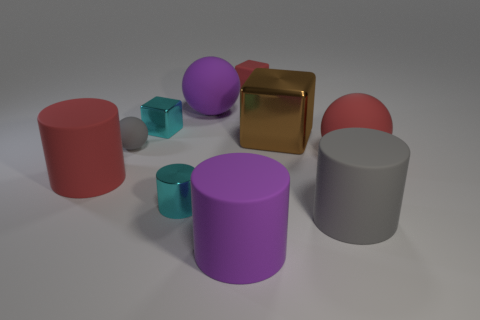The tiny cylinder has what color?
Your answer should be compact. Cyan. How many objects are shiny objects that are behind the tiny ball or green metallic spheres?
Make the answer very short. 2. Does the gray rubber cylinder that is in front of the large red rubber ball have the same size as the rubber cylinder on the left side of the large purple rubber sphere?
Keep it short and to the point. Yes. Is there any other thing that has the same material as the cyan cylinder?
Make the answer very short. Yes. What number of things are large shiny things that are in front of the rubber block or large red matte things that are on the left side of the small red cube?
Offer a terse response. 2. Do the small gray sphere and the big thing on the left side of the small sphere have the same material?
Your response must be concise. Yes. There is a big matte thing that is both on the left side of the big gray thing and in front of the small cyan metallic cylinder; what shape is it?
Provide a succinct answer. Cylinder. How many other things are the same color as the large shiny cube?
Keep it short and to the point. 0. The brown object has what shape?
Keep it short and to the point. Cube. What is the color of the small shiny object in front of the big red matte thing that is to the left of the small rubber block?
Provide a succinct answer. Cyan. 